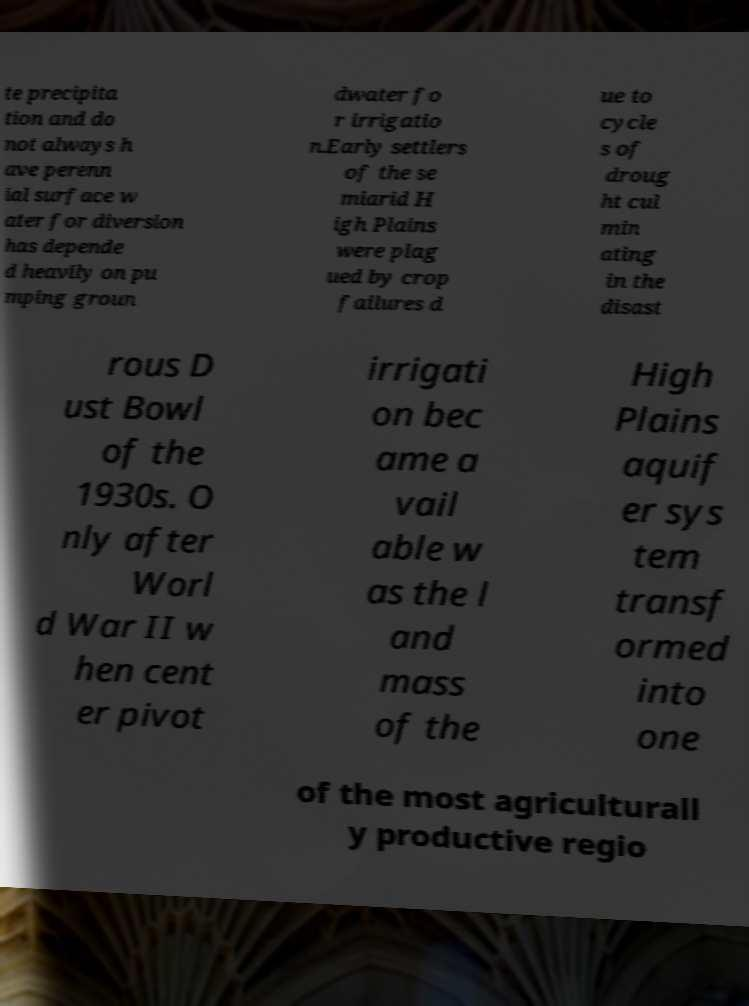Could you assist in decoding the text presented in this image and type it out clearly? te precipita tion and do not always h ave perenn ial surface w ater for diversion has depende d heavily on pu mping groun dwater fo r irrigatio n.Early settlers of the se miarid H igh Plains were plag ued by crop failures d ue to cycle s of droug ht cul min ating in the disast rous D ust Bowl of the 1930s. O nly after Worl d War II w hen cent er pivot irrigati on bec ame a vail able w as the l and mass of the High Plains aquif er sys tem transf ormed into one of the most agriculturall y productive regio 